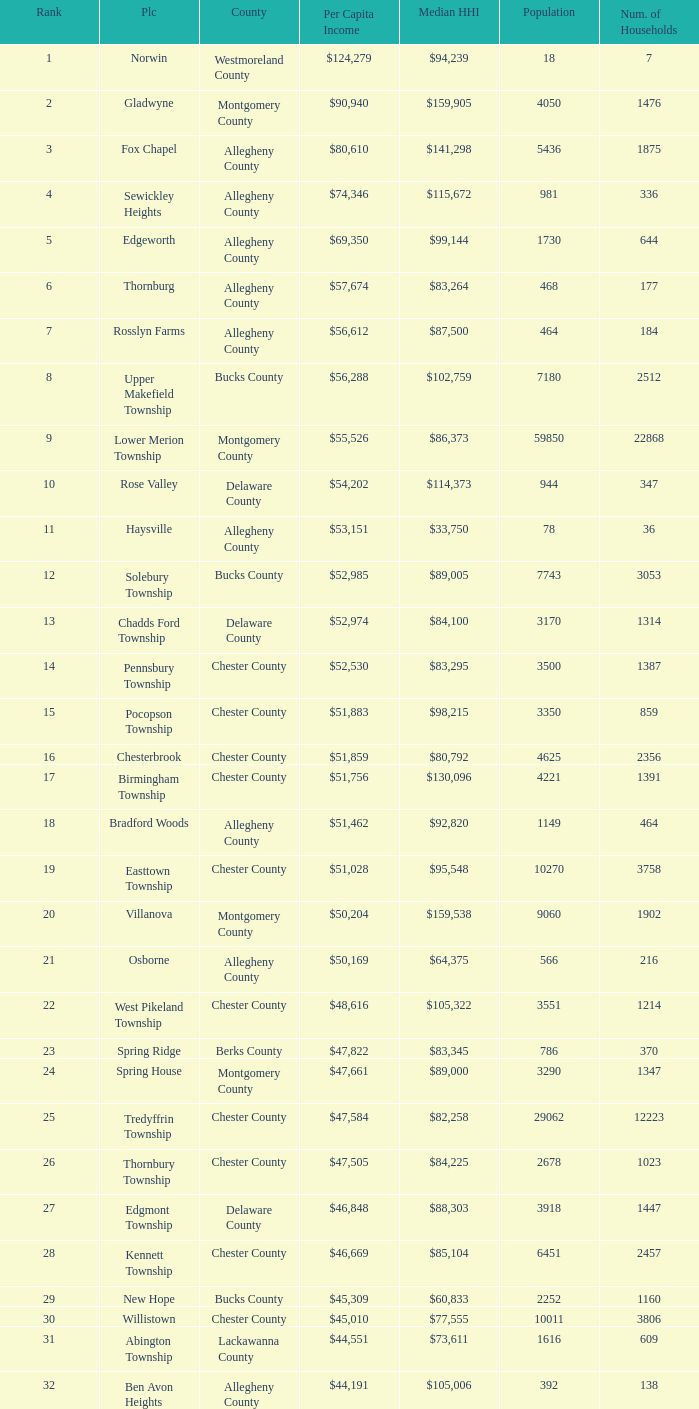Which place has a rank of 71? Wyomissing. 